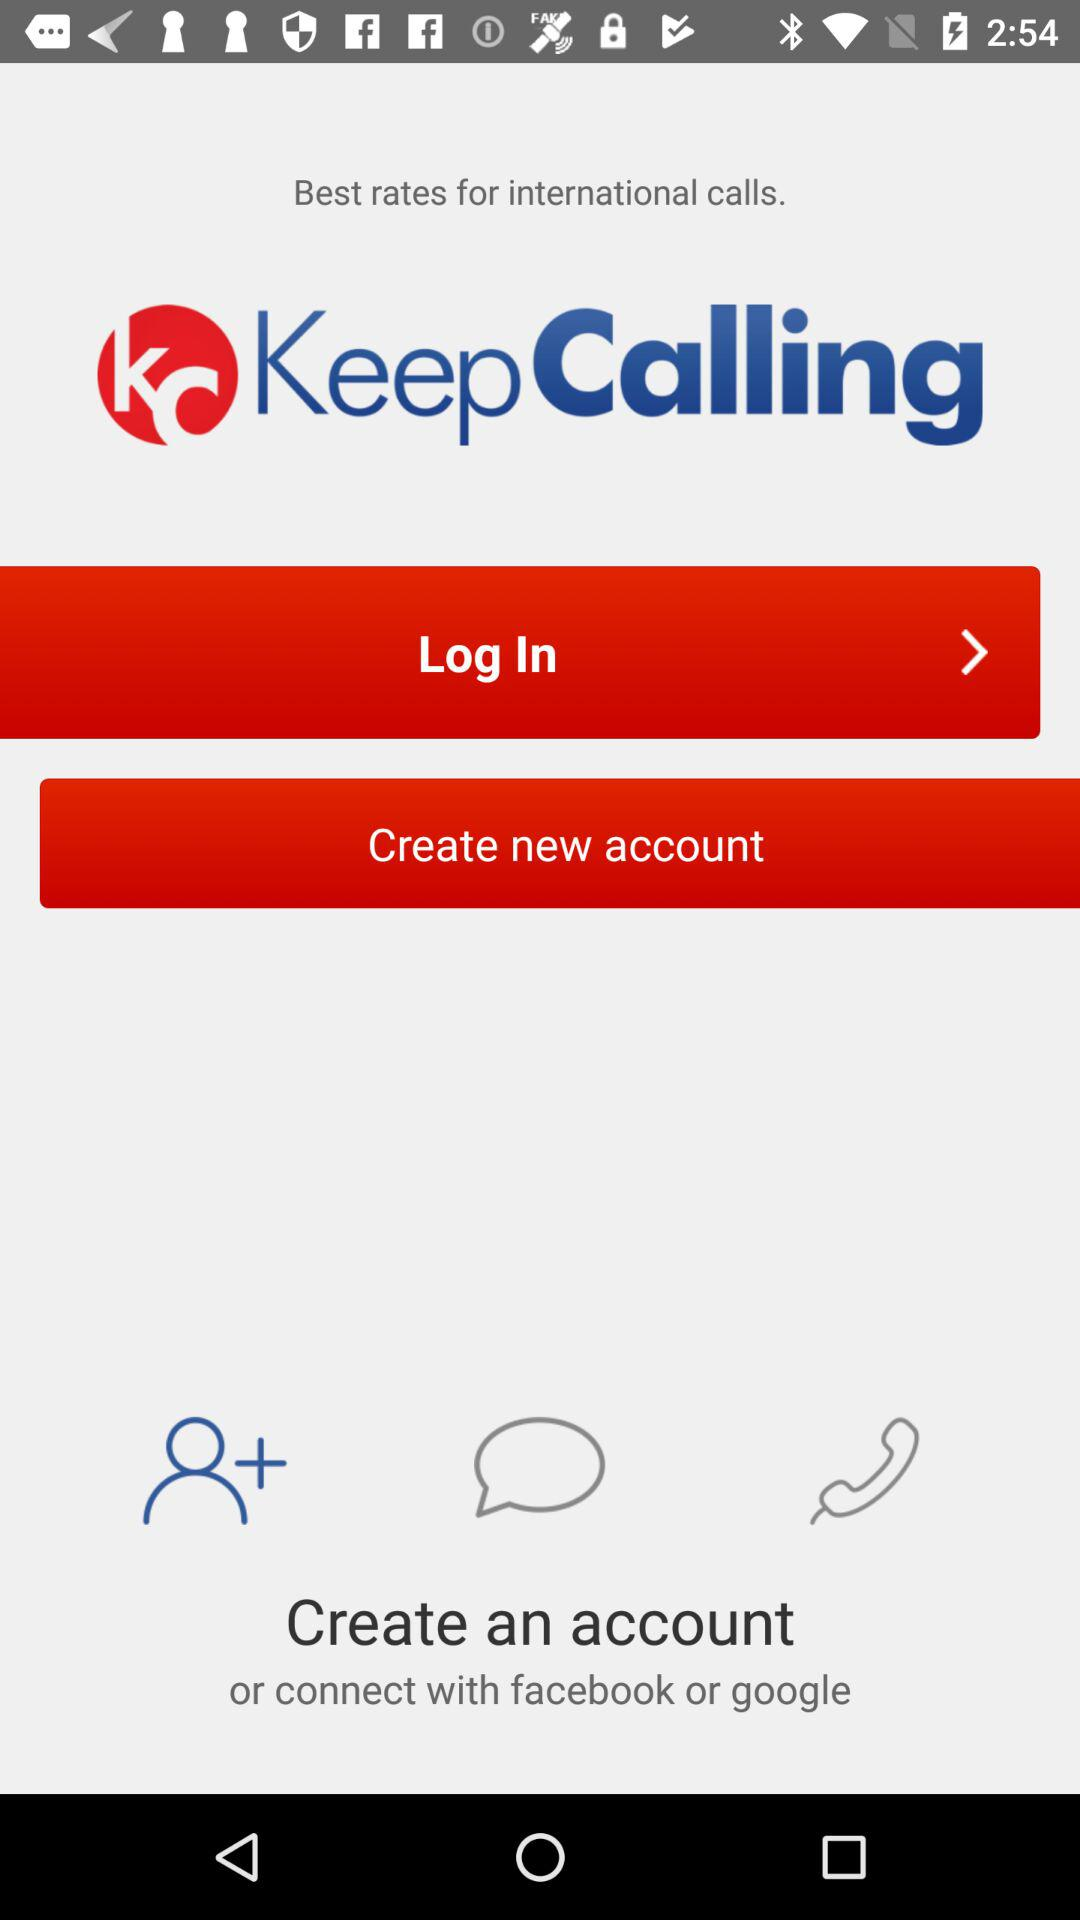What is the name of the application? The application is "KeepCalling". 